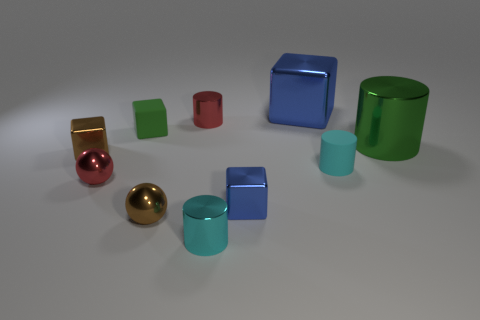How many cyan cylinders must be subtracted to get 1 cyan cylinders? 1 Subtract all cubes. How many objects are left? 6 Subtract 2 cylinders. How many cylinders are left? 2 Subtract all green spheres. Subtract all cyan blocks. How many spheres are left? 2 Subtract all cyan balls. How many green cylinders are left? 1 Subtract all blue shiny cubes. Subtract all small red things. How many objects are left? 6 Add 5 tiny shiny blocks. How many tiny shiny blocks are left? 7 Add 2 cyan metal cylinders. How many cyan metal cylinders exist? 3 Subtract all brown blocks. How many blocks are left? 3 Subtract all tiny cylinders. How many cylinders are left? 1 